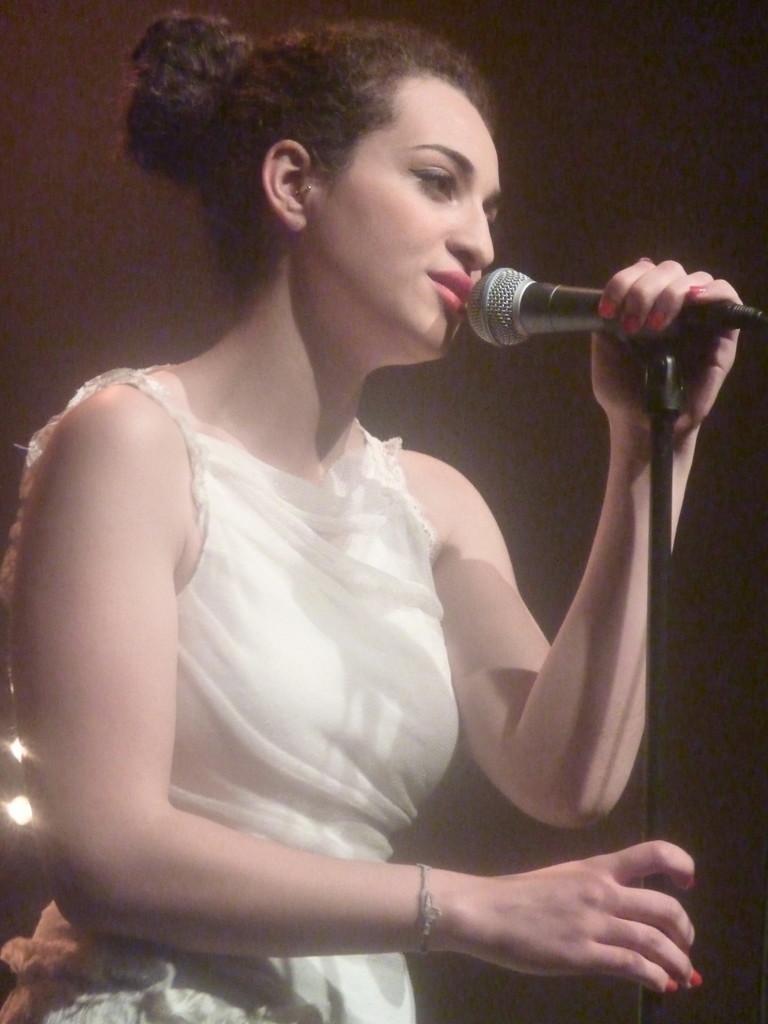Could you give a brief overview of what you see in this image? This picture contains woman who is wearing white color dress. He she is holding microphone in her hands and she is singing on it. 